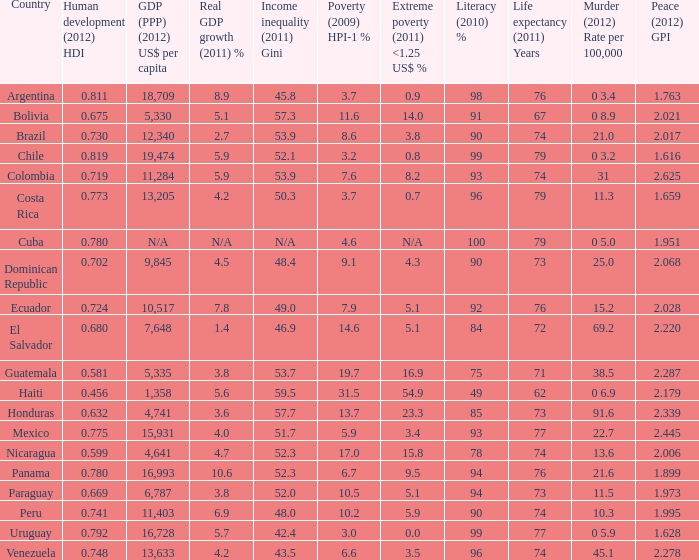For the year 2012, which country had a murder rate per 100,000 population and a global peace index of 1.616? 0 3.2. 